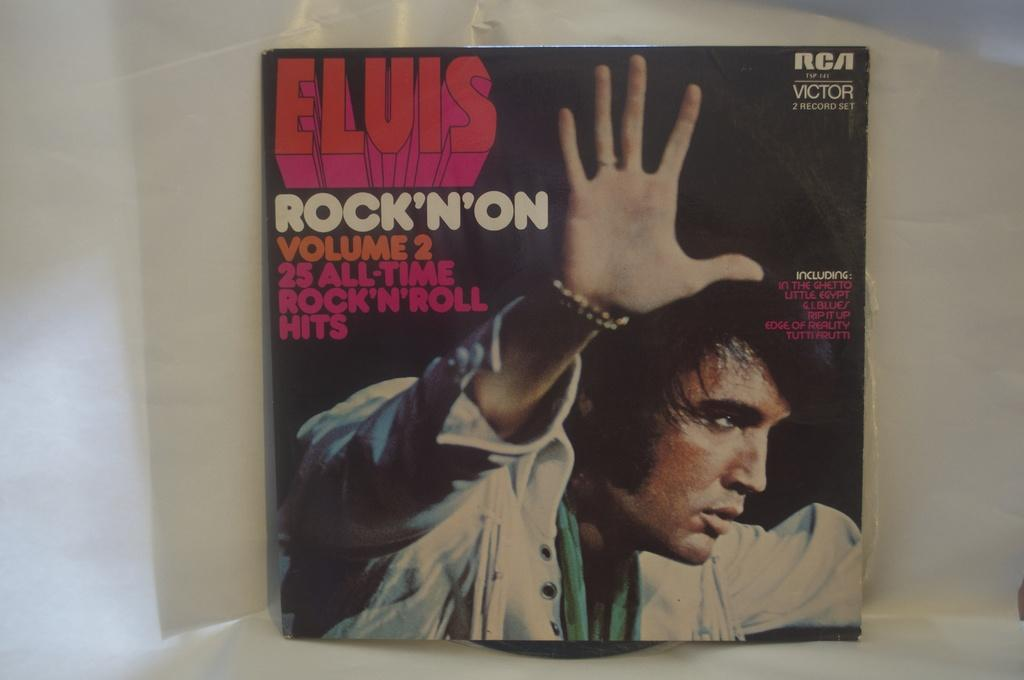<image>
Provide a brief description of the given image. Elvis rock n on volume two hits record 